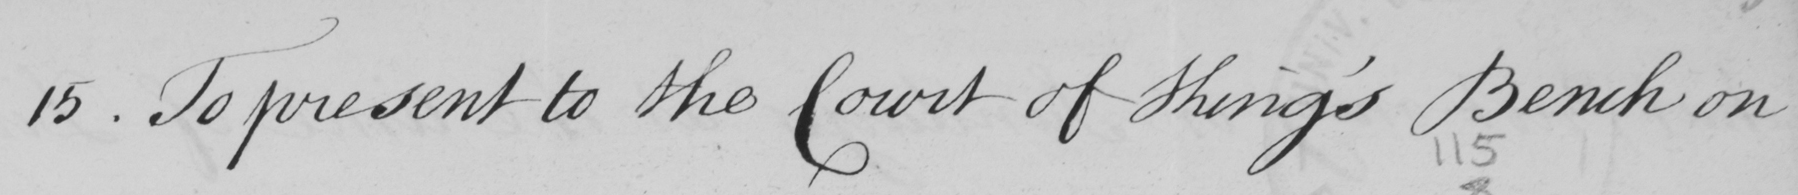What does this handwritten line say? 15 . To present to the Court of King ' s Bench on 